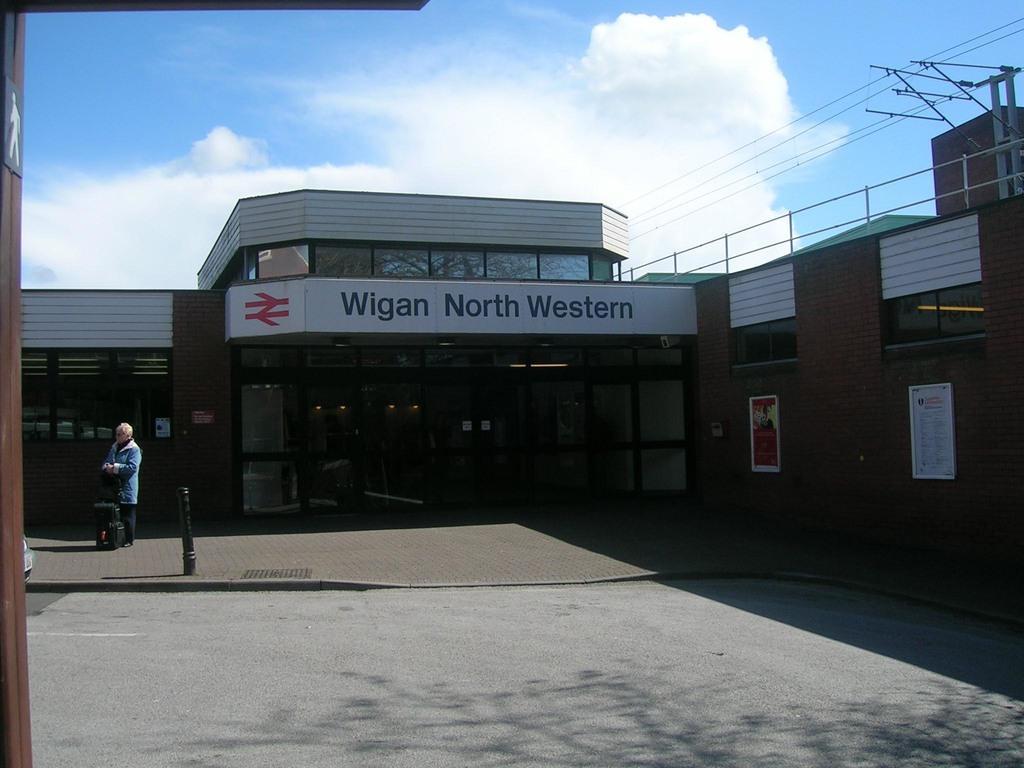Please provide a concise description of this image. In this image we can see a house with glass doors. At the top of the image there is sky and clouds. At the bottom of the image there is road. There is a person standing. To the left side of the image there is a pole. To the right side of the image there are electric wires and poles. 